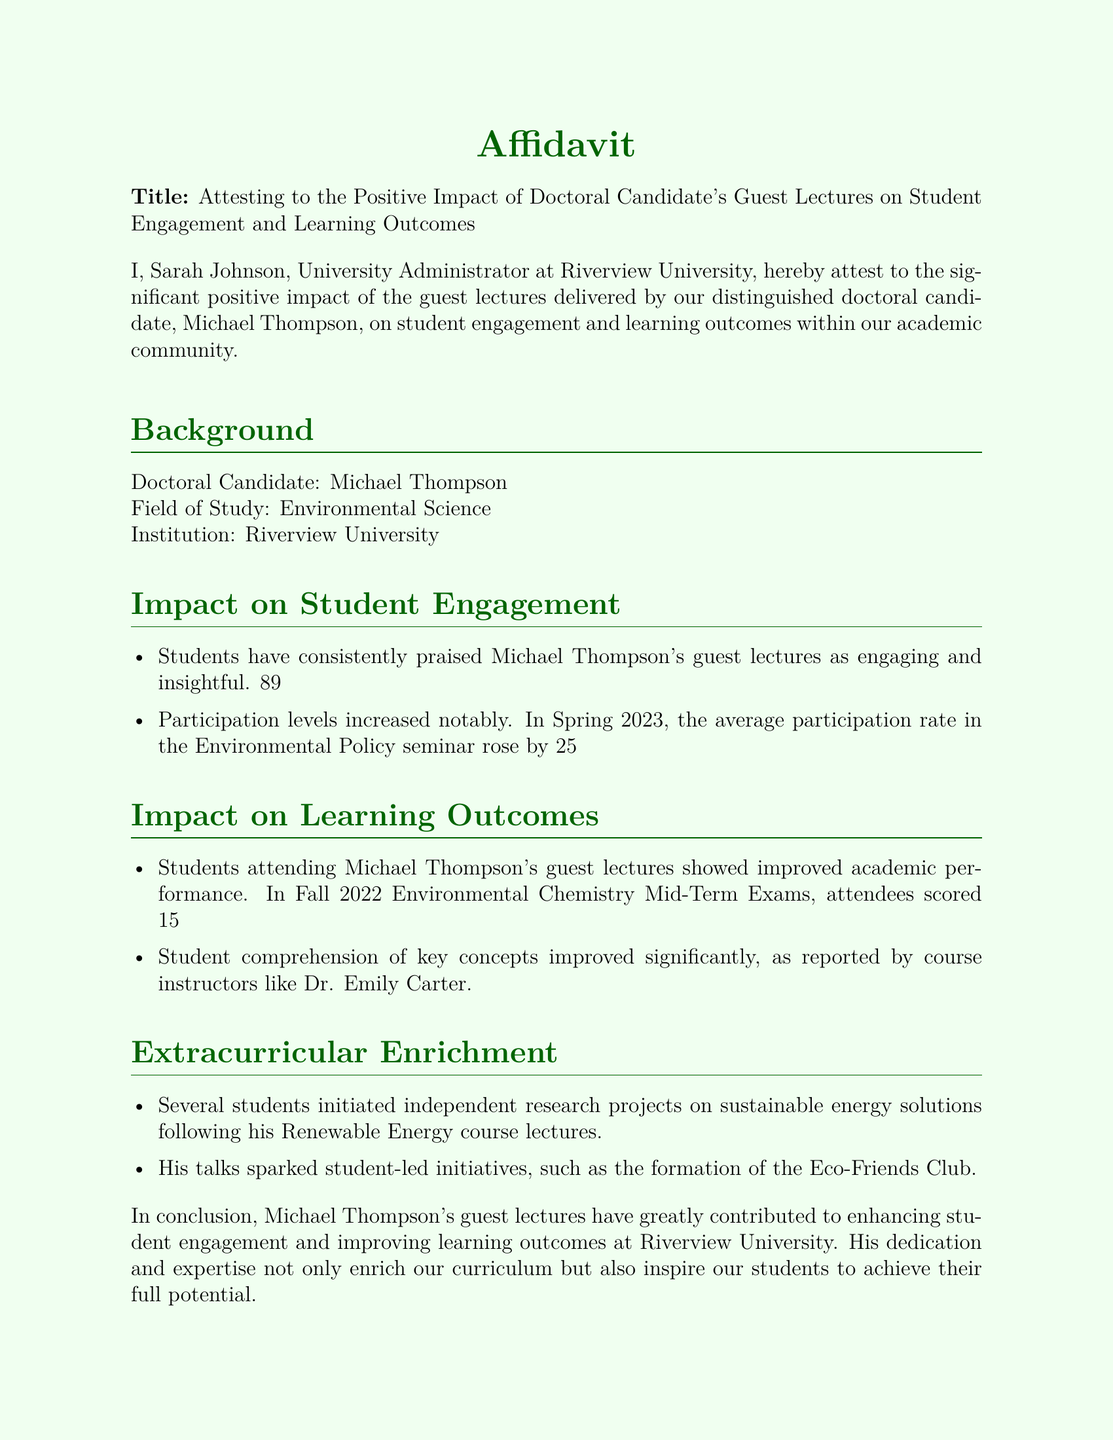What is the name of the doctoral candidate? The document lists Michael Thompson as the doctoral candidate.
Answer: Michael Thompson What is Michael Thompson's field of study? The affidavit specifies that Michael Thompson is studying Environmental Science.
Answer: Environmental Science What percentage of students rated his lectures as 'very engaging'? The document indicates that 89% of students rated his lectures as 'very engaging'.
Answer: 89% By what percentage did participation in the Environmental Policy seminar increase? It states that participation levels increased by 25% following his guest lectures.
Answer: 25% How much higher did attendees score on average in the Mid-Term Exams? The affidavit notes that attendees scored 15% higher on average in the Environmental Chemistry Mid-Term Exams.
Answer: 15% What organization was formed as a result of his talks? The document mentions the formation of the Eco-Friends Club as a student-led initiative.
Answer: Eco-Friends Club Who reported the improved comprehension of key concepts? The document cites course instructors such as Dr. Emily Carter regarding improved comprehension.
Answer: Dr. Emily Carter What date was the affidavit signed? The affidavit indicates that it was signed on October 12, 2023.
Answer: October 12, 2023 What university is Sarah Johnson affiliated with? The document states that Sarah Johnson is the University Administrator at Riverview University.
Answer: Riverview University 